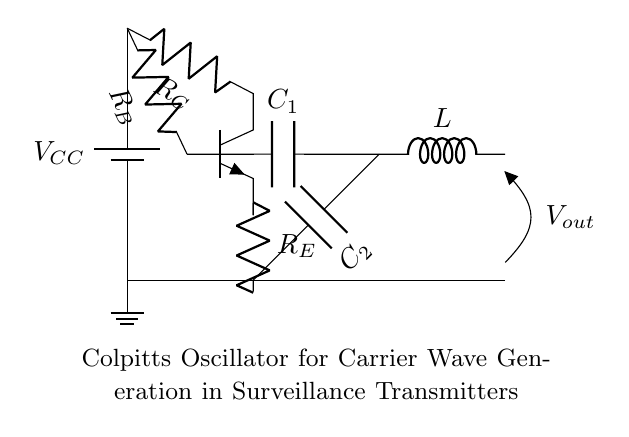What is the type of transistor used in the circuit? The circuit diagram shows an NP transistor, which is indicated by the symbol representing the transistor with an arrow pointing outwards on the emitter leg.
Answer: NP What is the voltage supply in this circuit? The circuit diagram labels the battery supply as V subscript CC, which indicates the supply voltage. The specific voltage value isn't indicated, but V CC signifies the main voltage source for this circuit.
Answer: V CC What is the role of capacitor C subscript 1? Capacitor C subscript 1 in the circuit is connected to the base of the transistor, and it plays a role in determining the frequency of the oscillation by forming part of the feedback network in a Colpitts oscillator.
Answer: Feedback What is connected to the collector of the transistor? The collector of the transistor is connected to resistor R subscript C, which is then connected to the voltage supply V subscript CC. This connection is essential for the transistor's operation, as it helps provide the necessary voltage drop for amplification.
Answer: Resistor R subscript C What is the purpose of inductor L in this oscillator circuit? Inductor L is part of the resonant circuit in the Colpitts oscillator, working together with the capacitors to set the oscillation frequency based on the values of L, C subscript 1, and C subscript 2, therefore it is crucial for generating carrier waves.
Answer: Resonance 